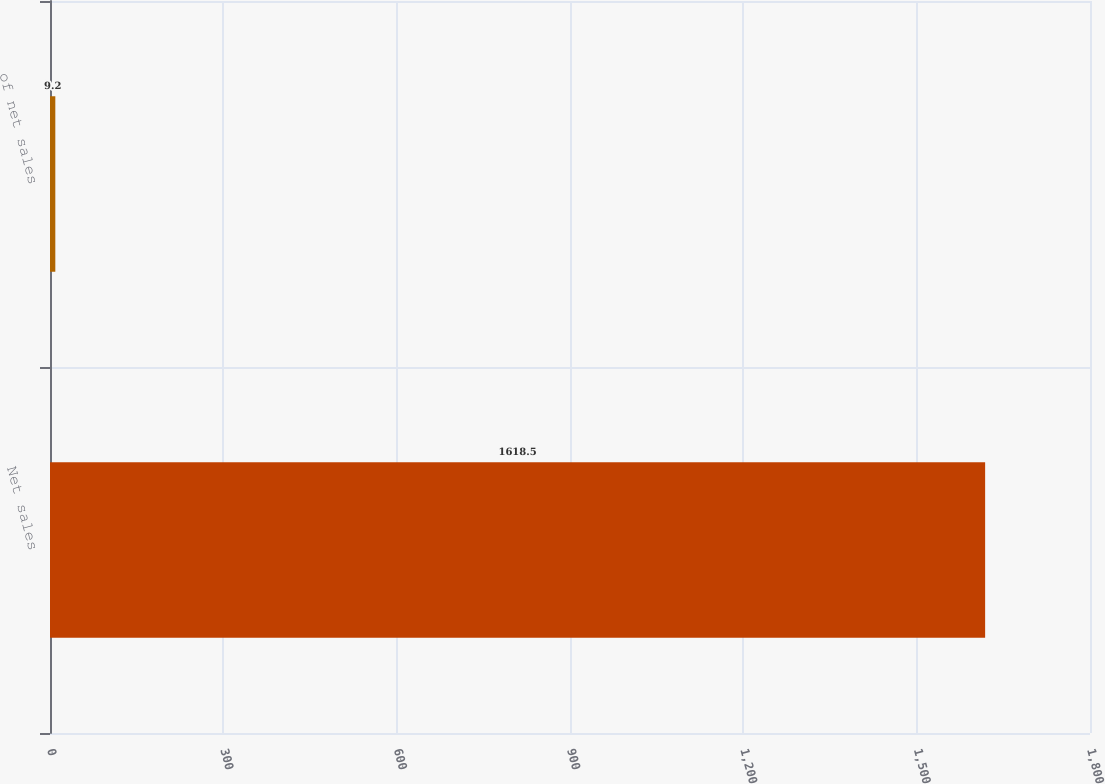Convert chart to OTSL. <chart><loc_0><loc_0><loc_500><loc_500><bar_chart><fcel>Net sales<fcel>of net sales<nl><fcel>1618.5<fcel>9.2<nl></chart> 